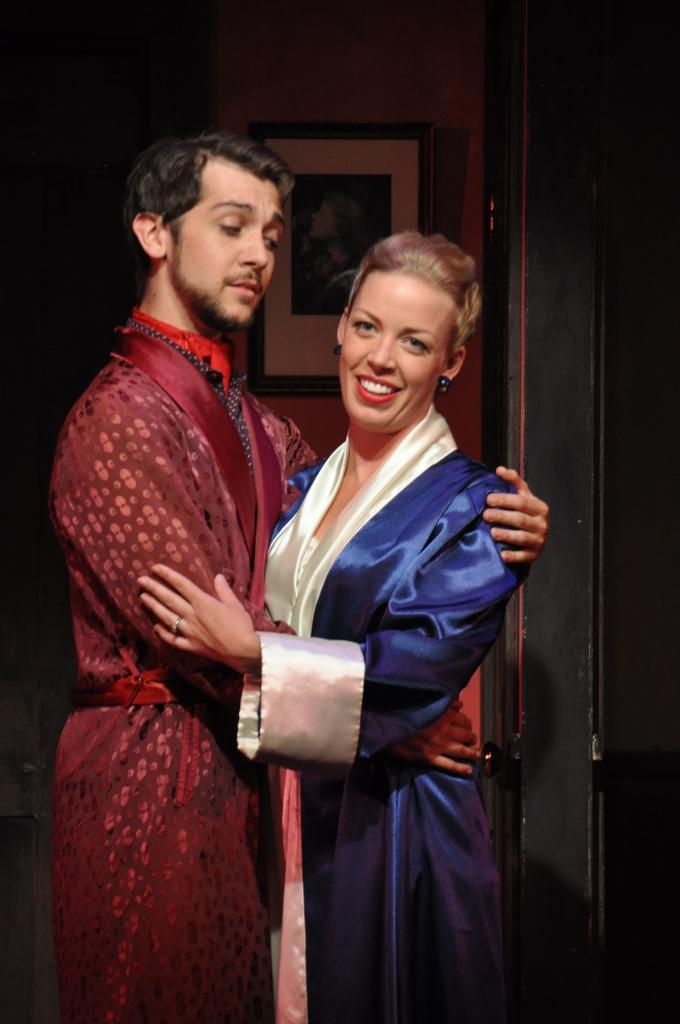Can you describe this image briefly? In this image there are two people standing and hugging each other, and at the background there is a frame attached to wall. 